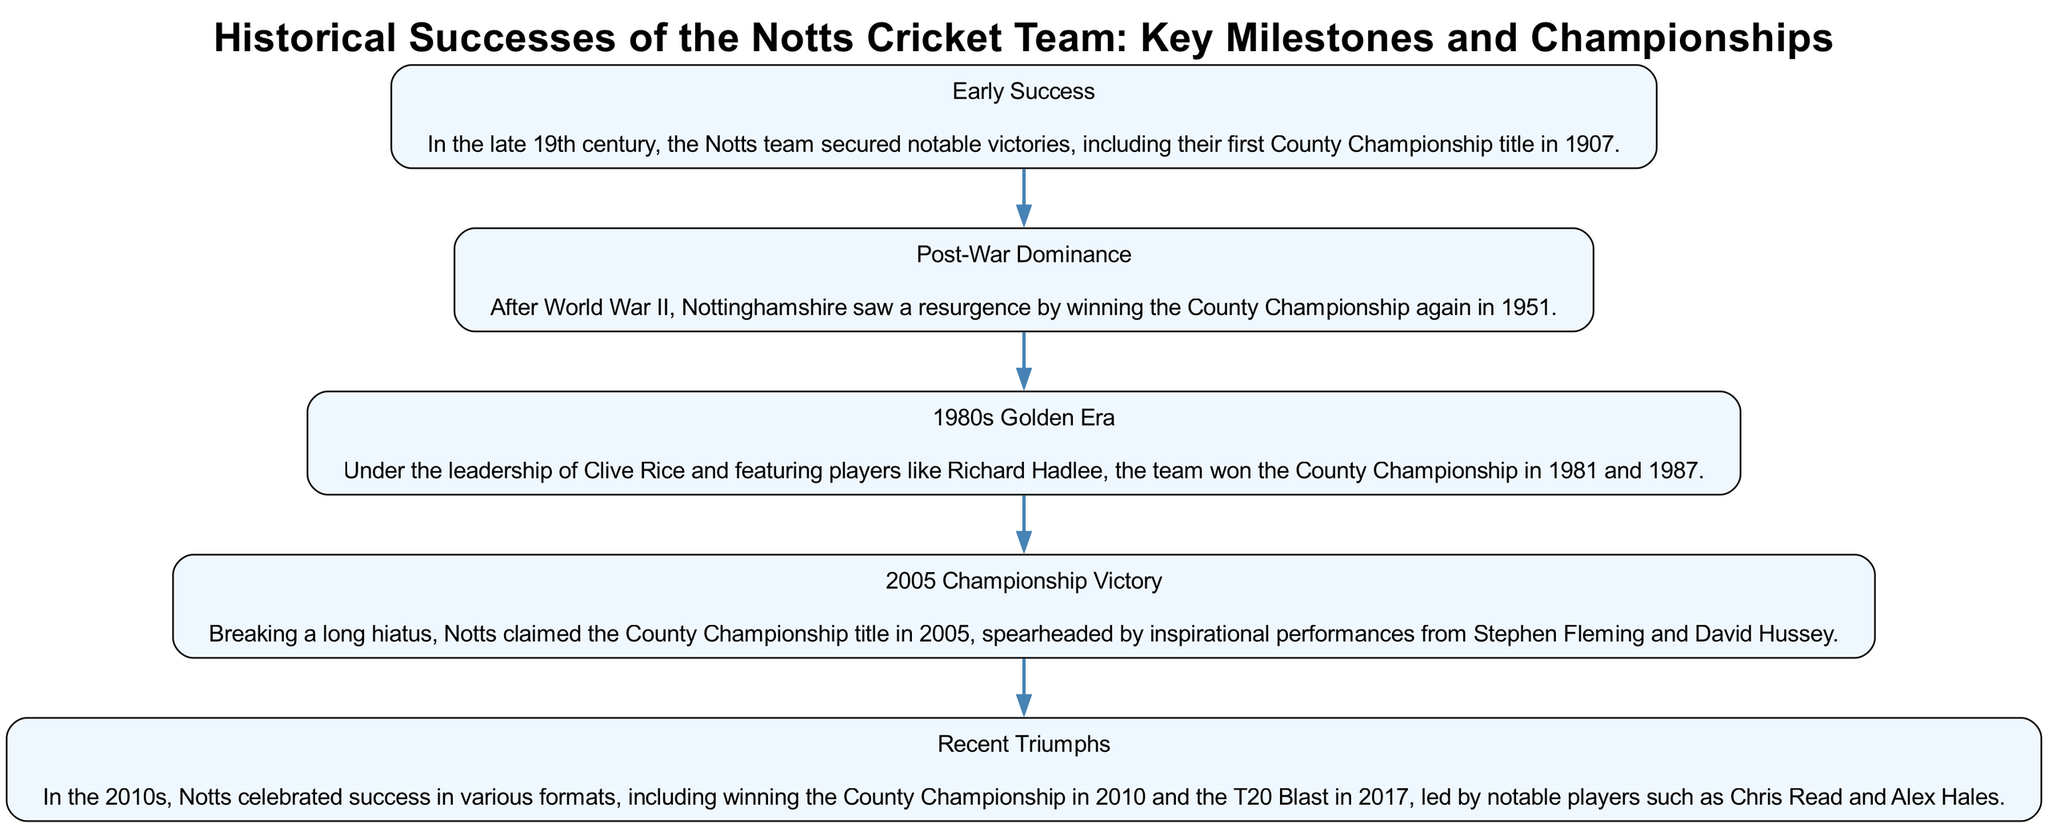What is the first milestone of Notts Cricket Team in the diagram? The first block titled "Early Success" indicates that the initial milestone was securing notable victories, including the first County Championship title in 1907.
Answer: Early Success In which year did Notts win the County Championship title after World War II? The block "Post-War Dominance" states that Nottinghamshire won the County Championship again in 1951.
Answer: 1951 How many significant championship victories are highlighted from the 1980s? The "1980s Golden Era" block mentions that the team won the County Championship in 1981 and 1987, making it two notable victories in that decade.
Answer: Two Which block details the County Championship victory achieved in 2005? The block titled "2005 Championship Victory" explicitly mentions the victory and describes the influential players associated with that achievement.
Answer: 2005 Championship Victory What significant T20 achievement does the "Recent Triumphs" block mention? The "Recent Triumphs" block describes the victory in the T20 Blast in 2017 as a key milestone.
Answer: T20 Blast 2017 Which player is associated with the Notts team in the 2005 County Championship victory? The "2005 Championship Victory" block mentions that Stephen Fleming was an inspirational player during that season, linking him directly to the championship title.
Answer: Stephen Fleming How does the "Post-War Dominance" block connect with earlier successful periods? The blocks are connected sequentially, where "Post-War Dominance" follows "Early Success," suggesting a continuation of strong performance in the team's history.
Answer: Continuation of Success What format of cricket did Notts win in 2010? The "Recent Triumphs" block indicates that Notts won the County Championship, specifically referring to achievements in that format in the year 2010.
Answer: County Championship 2010 